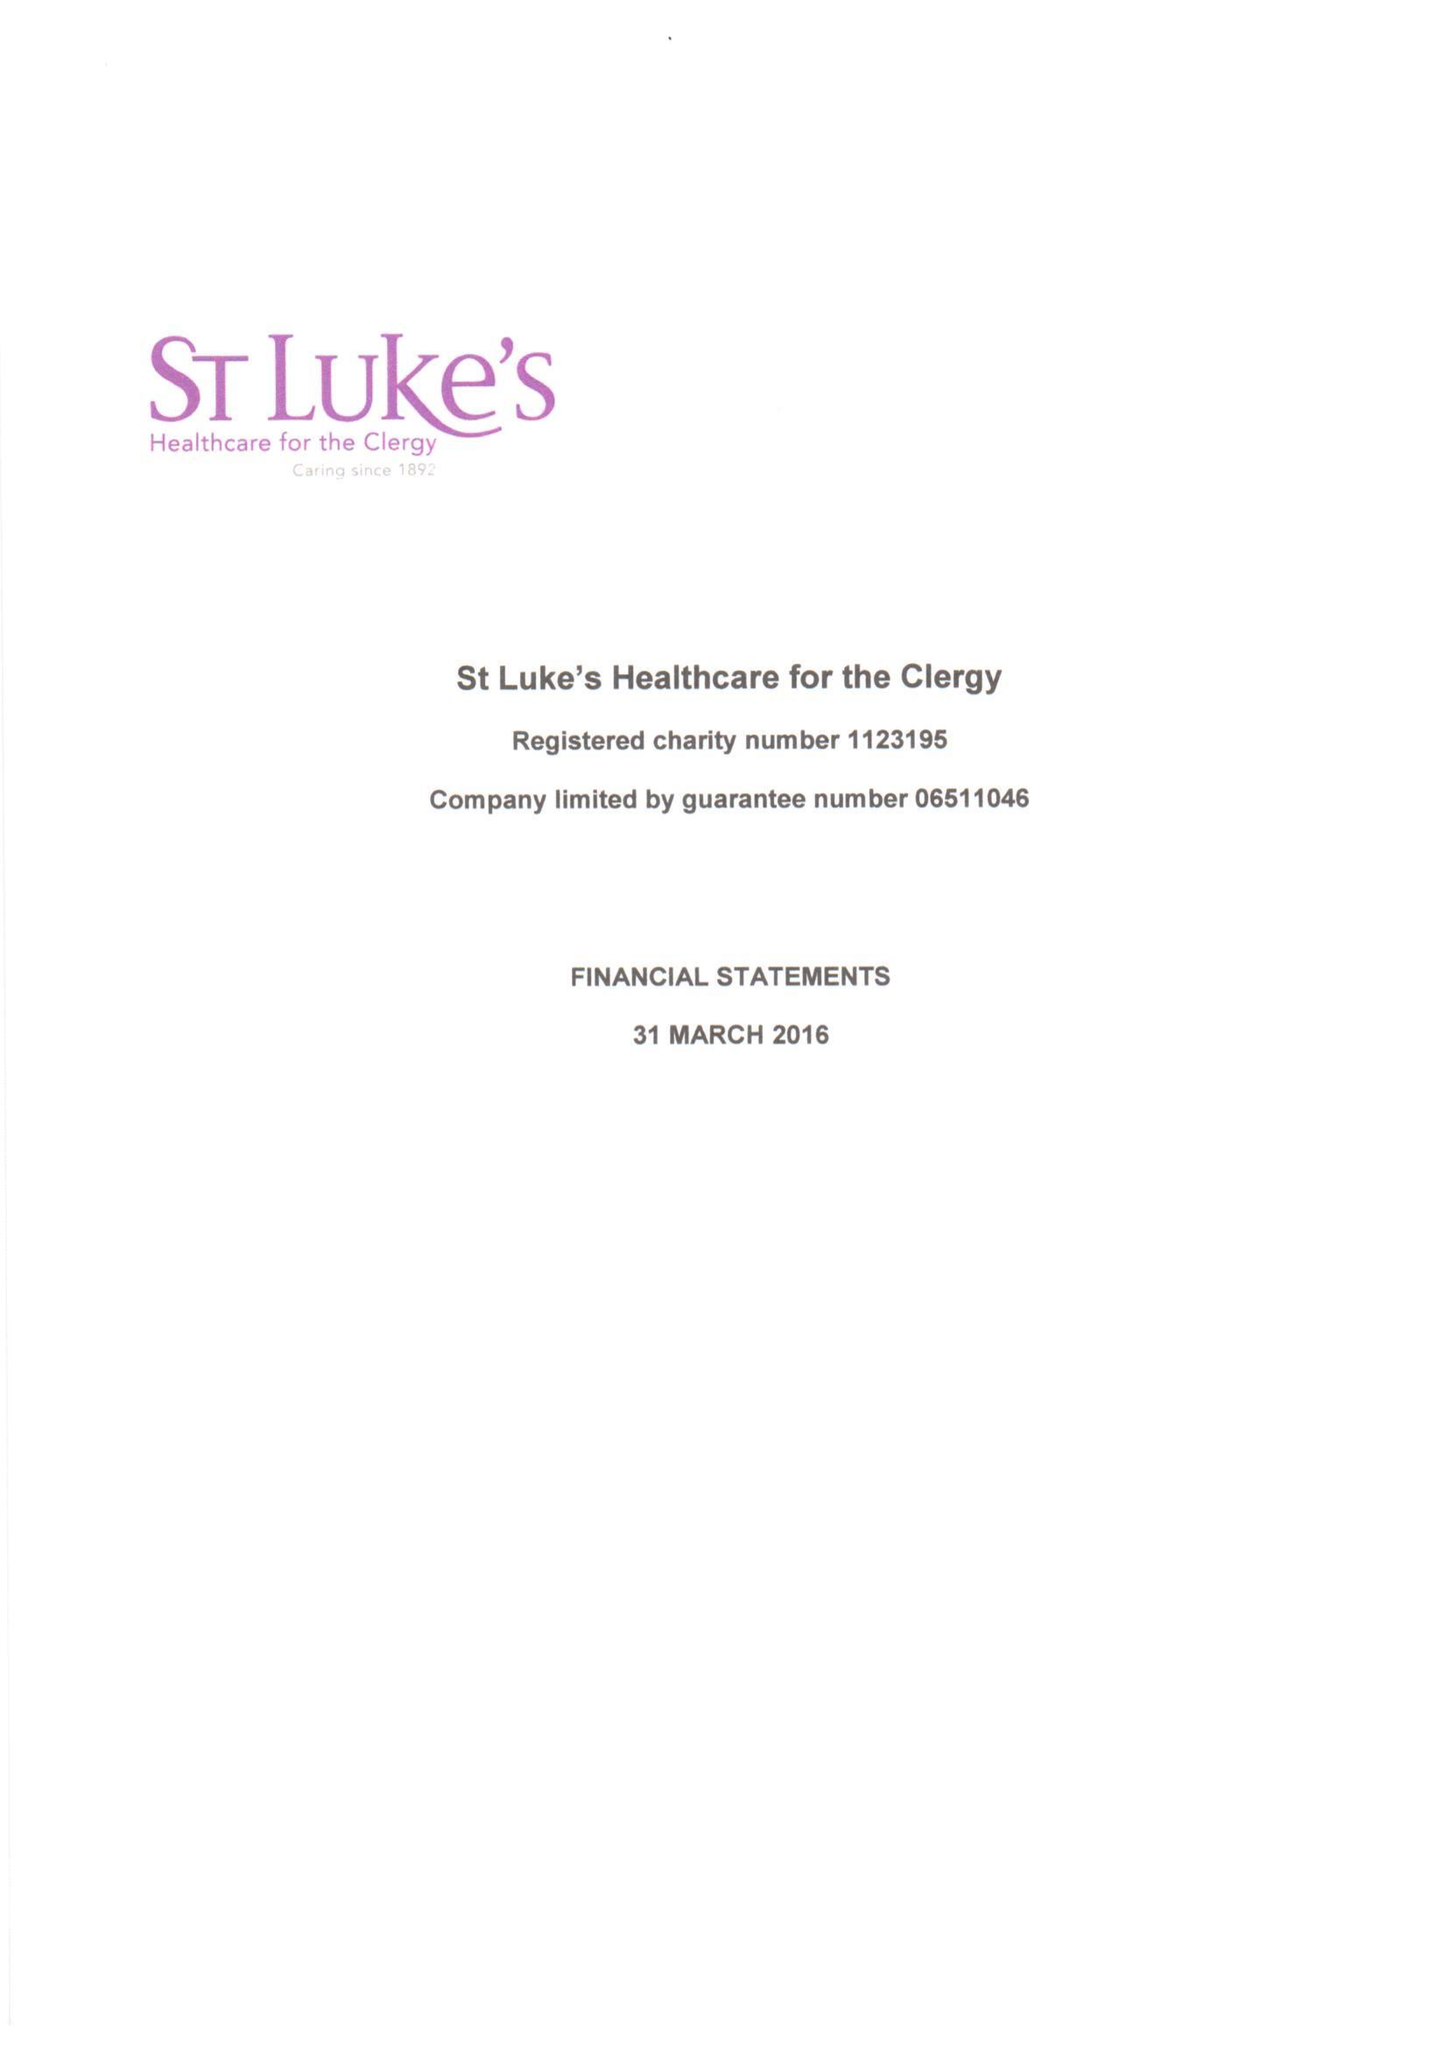What is the value for the address__postcode?
Answer the question using a single word or phrase. SW1P 3AZ 